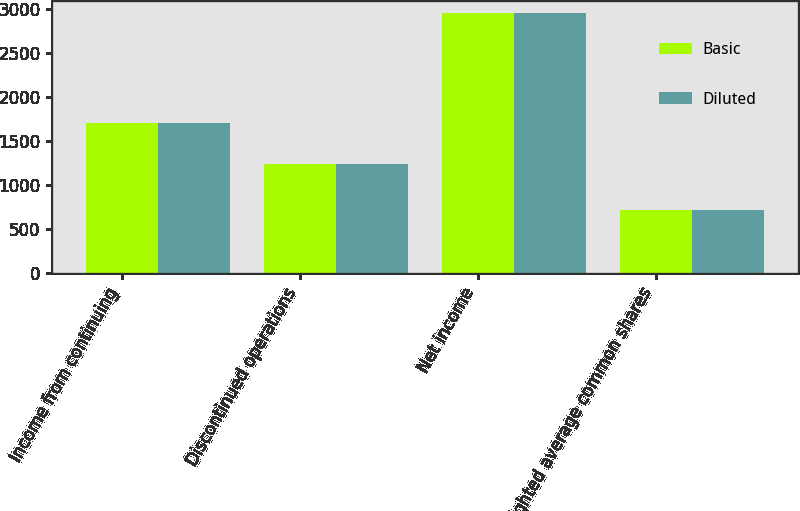Convert chart. <chart><loc_0><loc_0><loc_500><loc_500><stacked_bar_chart><ecel><fcel>Income from continuing<fcel>Discontinued operations<fcel>Net income<fcel>Weighted average common shares<nl><fcel>Basic<fcel>1707<fcel>1239<fcel>2946<fcel>710<nl><fcel>Diluted<fcel>1707<fcel>1239<fcel>2946<fcel>714<nl></chart> 